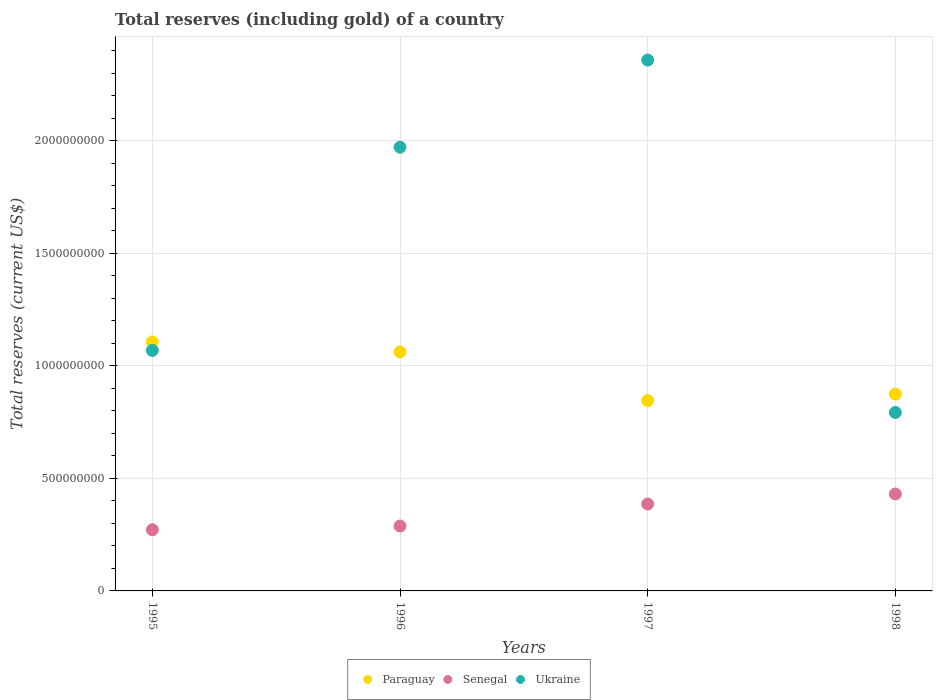How many different coloured dotlines are there?
Provide a succinct answer. 3. Is the number of dotlines equal to the number of legend labels?
Make the answer very short. Yes. What is the total reserves (including gold) in Senegal in 1997?
Give a very brief answer. 3.86e+08. Across all years, what is the maximum total reserves (including gold) in Ukraine?
Keep it short and to the point. 2.36e+09. Across all years, what is the minimum total reserves (including gold) in Paraguay?
Your answer should be very brief. 8.46e+08. What is the total total reserves (including gold) in Senegal in the graph?
Give a very brief answer. 1.38e+09. What is the difference between the total reserves (including gold) in Ukraine in 1995 and that in 1998?
Your response must be concise. 2.76e+08. What is the difference between the total reserves (including gold) in Ukraine in 1998 and the total reserves (including gold) in Paraguay in 1996?
Ensure brevity in your answer.  -2.69e+08. What is the average total reserves (including gold) in Ukraine per year?
Your response must be concise. 1.55e+09. In the year 1996, what is the difference between the total reserves (including gold) in Paraguay and total reserves (including gold) in Senegal?
Give a very brief answer. 7.74e+08. In how many years, is the total reserves (including gold) in Paraguay greater than 700000000 US$?
Offer a terse response. 4. What is the ratio of the total reserves (including gold) in Ukraine in 1996 to that in 1998?
Provide a short and direct response. 2.49. Is the total reserves (including gold) in Ukraine in 1996 less than that in 1997?
Provide a short and direct response. Yes. Is the difference between the total reserves (including gold) in Paraguay in 1997 and 1998 greater than the difference between the total reserves (including gold) in Senegal in 1997 and 1998?
Offer a very short reply. Yes. What is the difference between the highest and the second highest total reserves (including gold) in Ukraine?
Give a very brief answer. 3.87e+08. What is the difference between the highest and the lowest total reserves (including gold) in Ukraine?
Give a very brief answer. 1.57e+09. In how many years, is the total reserves (including gold) in Ukraine greater than the average total reserves (including gold) in Ukraine taken over all years?
Your response must be concise. 2. Is the total reserves (including gold) in Senegal strictly greater than the total reserves (including gold) in Paraguay over the years?
Your response must be concise. No. Is the total reserves (including gold) in Senegal strictly less than the total reserves (including gold) in Paraguay over the years?
Your answer should be very brief. Yes. What is the difference between two consecutive major ticks on the Y-axis?
Offer a very short reply. 5.00e+08. Are the values on the major ticks of Y-axis written in scientific E-notation?
Give a very brief answer. No. Does the graph contain any zero values?
Your answer should be very brief. No. Does the graph contain grids?
Offer a very short reply. Yes. What is the title of the graph?
Offer a terse response. Total reserves (including gold) of a country. Does "Eritrea" appear as one of the legend labels in the graph?
Offer a terse response. No. What is the label or title of the X-axis?
Ensure brevity in your answer.  Years. What is the label or title of the Y-axis?
Your answer should be compact. Total reserves (current US$). What is the Total reserves (current US$) in Paraguay in 1995?
Give a very brief answer. 1.11e+09. What is the Total reserves (current US$) of Senegal in 1995?
Make the answer very short. 2.72e+08. What is the Total reserves (current US$) of Ukraine in 1995?
Make the answer very short. 1.07e+09. What is the Total reserves (current US$) in Paraguay in 1996?
Offer a very short reply. 1.06e+09. What is the Total reserves (current US$) of Senegal in 1996?
Give a very brief answer. 2.88e+08. What is the Total reserves (current US$) in Ukraine in 1996?
Your answer should be very brief. 1.97e+09. What is the Total reserves (current US$) in Paraguay in 1997?
Provide a short and direct response. 8.46e+08. What is the Total reserves (current US$) in Senegal in 1997?
Provide a succinct answer. 3.86e+08. What is the Total reserves (current US$) of Ukraine in 1997?
Give a very brief answer. 2.36e+09. What is the Total reserves (current US$) of Paraguay in 1998?
Offer a very short reply. 8.75e+08. What is the Total reserves (current US$) in Senegal in 1998?
Your answer should be very brief. 4.31e+08. What is the Total reserves (current US$) of Ukraine in 1998?
Make the answer very short. 7.93e+08. Across all years, what is the maximum Total reserves (current US$) in Paraguay?
Your answer should be compact. 1.11e+09. Across all years, what is the maximum Total reserves (current US$) in Senegal?
Ensure brevity in your answer.  4.31e+08. Across all years, what is the maximum Total reserves (current US$) of Ukraine?
Provide a short and direct response. 2.36e+09. Across all years, what is the minimum Total reserves (current US$) of Paraguay?
Your answer should be compact. 8.46e+08. Across all years, what is the minimum Total reserves (current US$) in Senegal?
Provide a succinct answer. 2.72e+08. Across all years, what is the minimum Total reserves (current US$) of Ukraine?
Your answer should be very brief. 7.93e+08. What is the total Total reserves (current US$) in Paraguay in the graph?
Provide a succinct answer. 3.89e+09. What is the total Total reserves (current US$) in Senegal in the graph?
Offer a terse response. 1.38e+09. What is the total Total reserves (current US$) in Ukraine in the graph?
Offer a very short reply. 6.19e+09. What is the difference between the Total reserves (current US$) of Paraguay in 1995 and that in 1996?
Make the answer very short. 4.42e+07. What is the difference between the Total reserves (current US$) in Senegal in 1995 and that in 1996?
Offer a terse response. -1.65e+07. What is the difference between the Total reserves (current US$) in Ukraine in 1995 and that in 1996?
Your response must be concise. -9.03e+08. What is the difference between the Total reserves (current US$) of Paraguay in 1995 and that in 1997?
Provide a succinct answer. 2.61e+08. What is the difference between the Total reserves (current US$) in Senegal in 1995 and that in 1997?
Provide a short and direct response. -1.14e+08. What is the difference between the Total reserves (current US$) of Ukraine in 1995 and that in 1997?
Provide a short and direct response. -1.29e+09. What is the difference between the Total reserves (current US$) in Paraguay in 1995 and that in 1998?
Make the answer very short. 2.32e+08. What is the difference between the Total reserves (current US$) of Senegal in 1995 and that in 1998?
Your answer should be very brief. -1.59e+08. What is the difference between the Total reserves (current US$) in Ukraine in 1995 and that in 1998?
Provide a short and direct response. 2.76e+08. What is the difference between the Total reserves (current US$) of Paraguay in 1996 and that in 1997?
Give a very brief answer. 2.16e+08. What is the difference between the Total reserves (current US$) of Senegal in 1996 and that in 1997?
Provide a short and direct response. -9.79e+07. What is the difference between the Total reserves (current US$) of Ukraine in 1996 and that in 1997?
Give a very brief answer. -3.87e+08. What is the difference between the Total reserves (current US$) of Paraguay in 1996 and that in 1998?
Give a very brief answer. 1.87e+08. What is the difference between the Total reserves (current US$) of Senegal in 1996 and that in 1998?
Ensure brevity in your answer.  -1.43e+08. What is the difference between the Total reserves (current US$) in Ukraine in 1996 and that in 1998?
Make the answer very short. 1.18e+09. What is the difference between the Total reserves (current US$) in Paraguay in 1997 and that in 1998?
Keep it short and to the point. -2.90e+07. What is the difference between the Total reserves (current US$) of Senegal in 1997 and that in 1998?
Provide a succinct answer. -4.46e+07. What is the difference between the Total reserves (current US$) in Ukraine in 1997 and that in 1998?
Provide a succinct answer. 1.57e+09. What is the difference between the Total reserves (current US$) of Paraguay in 1995 and the Total reserves (current US$) of Senegal in 1996?
Offer a terse response. 8.18e+08. What is the difference between the Total reserves (current US$) in Paraguay in 1995 and the Total reserves (current US$) in Ukraine in 1996?
Provide a succinct answer. -8.65e+08. What is the difference between the Total reserves (current US$) in Senegal in 1995 and the Total reserves (current US$) in Ukraine in 1996?
Your answer should be very brief. -1.70e+09. What is the difference between the Total reserves (current US$) in Paraguay in 1995 and the Total reserves (current US$) in Senegal in 1997?
Ensure brevity in your answer.  7.20e+08. What is the difference between the Total reserves (current US$) of Paraguay in 1995 and the Total reserves (current US$) of Ukraine in 1997?
Offer a terse response. -1.25e+09. What is the difference between the Total reserves (current US$) in Senegal in 1995 and the Total reserves (current US$) in Ukraine in 1997?
Offer a terse response. -2.09e+09. What is the difference between the Total reserves (current US$) of Paraguay in 1995 and the Total reserves (current US$) of Senegal in 1998?
Keep it short and to the point. 6.76e+08. What is the difference between the Total reserves (current US$) in Paraguay in 1995 and the Total reserves (current US$) in Ukraine in 1998?
Ensure brevity in your answer.  3.13e+08. What is the difference between the Total reserves (current US$) of Senegal in 1995 and the Total reserves (current US$) of Ukraine in 1998?
Offer a very short reply. -5.21e+08. What is the difference between the Total reserves (current US$) of Paraguay in 1996 and the Total reserves (current US$) of Senegal in 1997?
Ensure brevity in your answer.  6.76e+08. What is the difference between the Total reserves (current US$) of Paraguay in 1996 and the Total reserves (current US$) of Ukraine in 1997?
Make the answer very short. -1.30e+09. What is the difference between the Total reserves (current US$) in Senegal in 1996 and the Total reserves (current US$) in Ukraine in 1997?
Offer a terse response. -2.07e+09. What is the difference between the Total reserves (current US$) in Paraguay in 1996 and the Total reserves (current US$) in Senegal in 1998?
Your answer should be compact. 6.31e+08. What is the difference between the Total reserves (current US$) of Paraguay in 1996 and the Total reserves (current US$) of Ukraine in 1998?
Offer a terse response. 2.69e+08. What is the difference between the Total reserves (current US$) of Senegal in 1996 and the Total reserves (current US$) of Ukraine in 1998?
Offer a terse response. -5.05e+08. What is the difference between the Total reserves (current US$) in Paraguay in 1997 and the Total reserves (current US$) in Senegal in 1998?
Offer a terse response. 4.15e+08. What is the difference between the Total reserves (current US$) of Paraguay in 1997 and the Total reserves (current US$) of Ukraine in 1998?
Make the answer very short. 5.29e+07. What is the difference between the Total reserves (current US$) of Senegal in 1997 and the Total reserves (current US$) of Ukraine in 1998?
Your answer should be very brief. -4.07e+08. What is the average Total reserves (current US$) in Paraguay per year?
Keep it short and to the point. 9.72e+08. What is the average Total reserves (current US$) in Senegal per year?
Keep it short and to the point. 3.44e+08. What is the average Total reserves (current US$) of Ukraine per year?
Your response must be concise. 1.55e+09. In the year 1995, what is the difference between the Total reserves (current US$) in Paraguay and Total reserves (current US$) in Senegal?
Your answer should be very brief. 8.35e+08. In the year 1995, what is the difference between the Total reserves (current US$) in Paraguay and Total reserves (current US$) in Ukraine?
Offer a very short reply. 3.77e+07. In the year 1995, what is the difference between the Total reserves (current US$) in Senegal and Total reserves (current US$) in Ukraine?
Make the answer very short. -7.97e+08. In the year 1996, what is the difference between the Total reserves (current US$) of Paraguay and Total reserves (current US$) of Senegal?
Offer a terse response. 7.74e+08. In the year 1996, what is the difference between the Total reserves (current US$) of Paraguay and Total reserves (current US$) of Ukraine?
Provide a succinct answer. -9.09e+08. In the year 1996, what is the difference between the Total reserves (current US$) of Senegal and Total reserves (current US$) of Ukraine?
Offer a very short reply. -1.68e+09. In the year 1997, what is the difference between the Total reserves (current US$) of Paraguay and Total reserves (current US$) of Senegal?
Your answer should be compact. 4.60e+08. In the year 1997, what is the difference between the Total reserves (current US$) in Paraguay and Total reserves (current US$) in Ukraine?
Ensure brevity in your answer.  -1.51e+09. In the year 1997, what is the difference between the Total reserves (current US$) in Senegal and Total reserves (current US$) in Ukraine?
Your response must be concise. -1.97e+09. In the year 1998, what is the difference between the Total reserves (current US$) of Paraguay and Total reserves (current US$) of Senegal?
Keep it short and to the point. 4.44e+08. In the year 1998, what is the difference between the Total reserves (current US$) of Paraguay and Total reserves (current US$) of Ukraine?
Your answer should be very brief. 8.18e+07. In the year 1998, what is the difference between the Total reserves (current US$) of Senegal and Total reserves (current US$) of Ukraine?
Your answer should be very brief. -3.62e+08. What is the ratio of the Total reserves (current US$) in Paraguay in 1995 to that in 1996?
Provide a succinct answer. 1.04. What is the ratio of the Total reserves (current US$) of Senegal in 1995 to that in 1996?
Offer a terse response. 0.94. What is the ratio of the Total reserves (current US$) of Ukraine in 1995 to that in 1996?
Your answer should be very brief. 0.54. What is the ratio of the Total reserves (current US$) in Paraguay in 1995 to that in 1997?
Make the answer very short. 1.31. What is the ratio of the Total reserves (current US$) of Senegal in 1995 to that in 1997?
Your response must be concise. 0.7. What is the ratio of the Total reserves (current US$) in Ukraine in 1995 to that in 1997?
Provide a short and direct response. 0.45. What is the ratio of the Total reserves (current US$) in Paraguay in 1995 to that in 1998?
Offer a terse response. 1.26. What is the ratio of the Total reserves (current US$) of Senegal in 1995 to that in 1998?
Your response must be concise. 0.63. What is the ratio of the Total reserves (current US$) in Ukraine in 1995 to that in 1998?
Your answer should be compact. 1.35. What is the ratio of the Total reserves (current US$) of Paraguay in 1996 to that in 1997?
Provide a succinct answer. 1.26. What is the ratio of the Total reserves (current US$) in Senegal in 1996 to that in 1997?
Give a very brief answer. 0.75. What is the ratio of the Total reserves (current US$) of Ukraine in 1996 to that in 1997?
Provide a succinct answer. 0.84. What is the ratio of the Total reserves (current US$) in Paraguay in 1996 to that in 1998?
Provide a succinct answer. 1.21. What is the ratio of the Total reserves (current US$) of Senegal in 1996 to that in 1998?
Your answer should be compact. 0.67. What is the ratio of the Total reserves (current US$) in Ukraine in 1996 to that in 1998?
Offer a very short reply. 2.49. What is the ratio of the Total reserves (current US$) in Paraguay in 1997 to that in 1998?
Your answer should be compact. 0.97. What is the ratio of the Total reserves (current US$) of Senegal in 1997 to that in 1998?
Provide a short and direct response. 0.9. What is the ratio of the Total reserves (current US$) in Ukraine in 1997 to that in 1998?
Your response must be concise. 2.97. What is the difference between the highest and the second highest Total reserves (current US$) of Paraguay?
Provide a short and direct response. 4.42e+07. What is the difference between the highest and the second highest Total reserves (current US$) in Senegal?
Keep it short and to the point. 4.46e+07. What is the difference between the highest and the second highest Total reserves (current US$) in Ukraine?
Provide a succinct answer. 3.87e+08. What is the difference between the highest and the lowest Total reserves (current US$) in Paraguay?
Offer a terse response. 2.61e+08. What is the difference between the highest and the lowest Total reserves (current US$) in Senegal?
Offer a very short reply. 1.59e+08. What is the difference between the highest and the lowest Total reserves (current US$) of Ukraine?
Offer a terse response. 1.57e+09. 